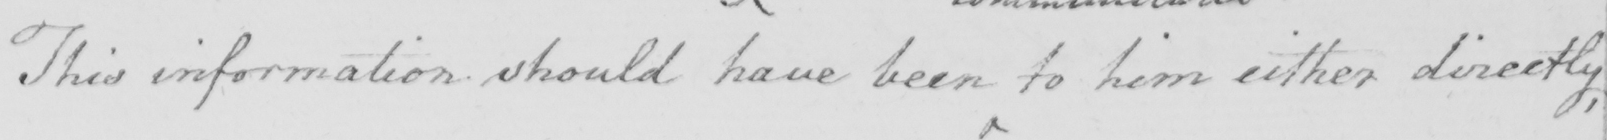What is written in this line of handwriting? This information should have been to him either directly , 